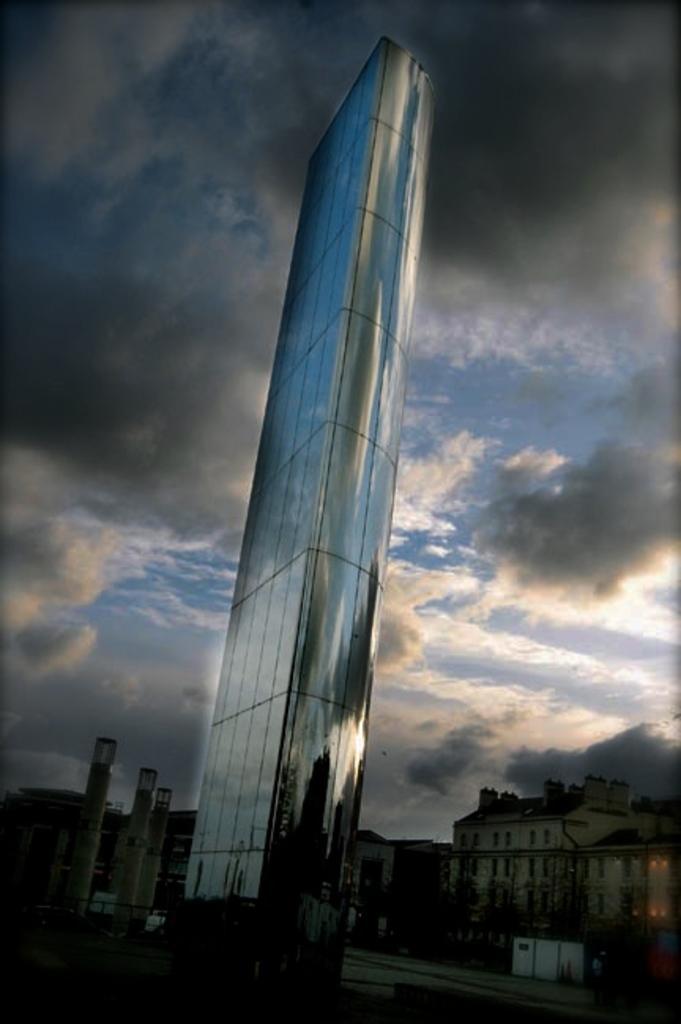Can you describe this image briefly? In this image there are trees, buildings and roads, at the top of the image there are clouds in the sky. 